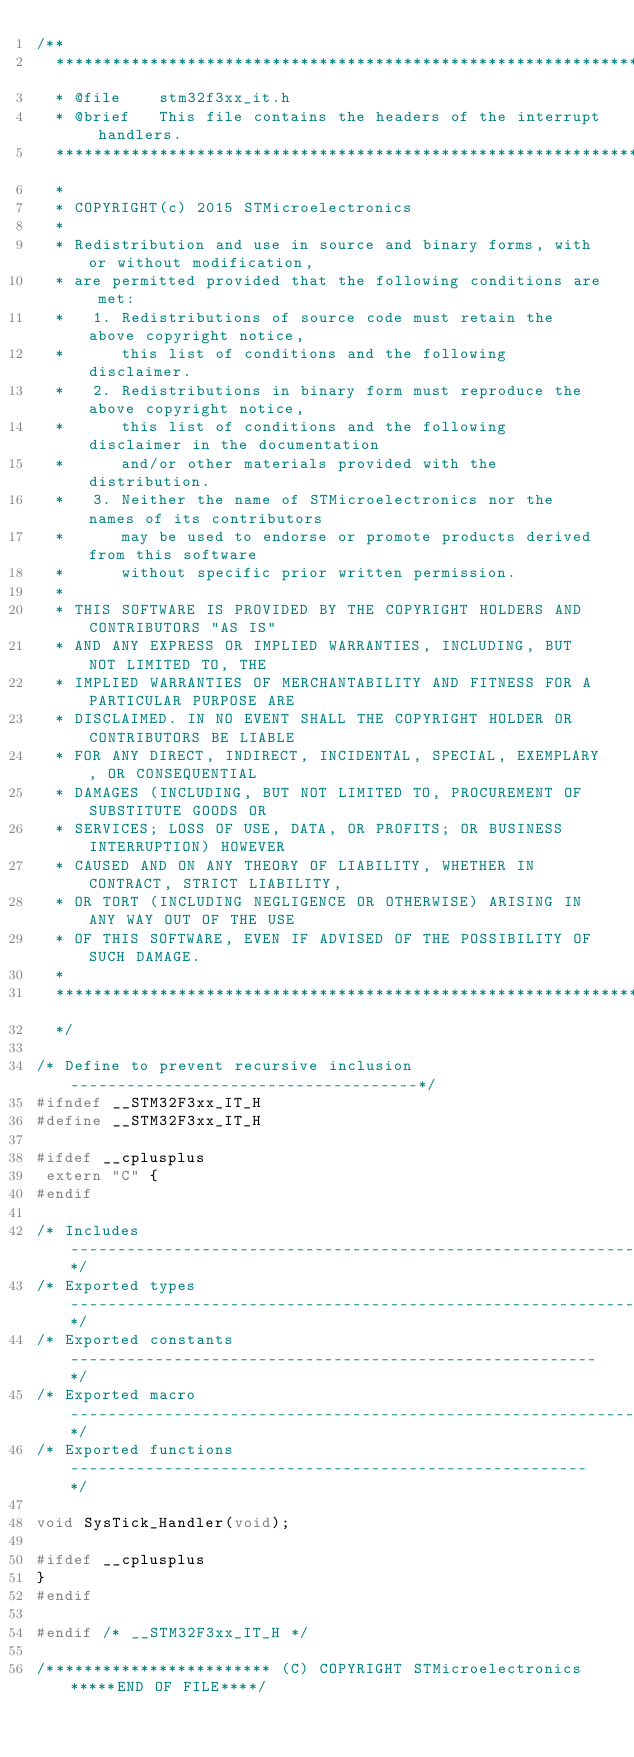<code> <loc_0><loc_0><loc_500><loc_500><_C_>/**
  ******************************************************************************
  * @file    stm32f3xx_it.h
  * @brief   This file contains the headers of the interrupt handlers.
  ******************************************************************************
  *
  * COPYRIGHT(c) 2015 STMicroelectronics
  *
  * Redistribution and use in source and binary forms, with or without modification,
  * are permitted provided that the following conditions are met:
  *   1. Redistributions of source code must retain the above copyright notice,
  *      this list of conditions and the following disclaimer.
  *   2. Redistributions in binary form must reproduce the above copyright notice,
  *      this list of conditions and the following disclaimer in the documentation
  *      and/or other materials provided with the distribution.
  *   3. Neither the name of STMicroelectronics nor the names of its contributors
  *      may be used to endorse or promote products derived from this software
  *      without specific prior written permission.
  *
  * THIS SOFTWARE IS PROVIDED BY THE COPYRIGHT HOLDERS AND CONTRIBUTORS "AS IS"
  * AND ANY EXPRESS OR IMPLIED WARRANTIES, INCLUDING, BUT NOT LIMITED TO, THE
  * IMPLIED WARRANTIES OF MERCHANTABILITY AND FITNESS FOR A PARTICULAR PURPOSE ARE
  * DISCLAIMED. IN NO EVENT SHALL THE COPYRIGHT HOLDER OR CONTRIBUTORS BE LIABLE
  * FOR ANY DIRECT, INDIRECT, INCIDENTAL, SPECIAL, EXEMPLARY, OR CONSEQUENTIAL
  * DAMAGES (INCLUDING, BUT NOT LIMITED TO, PROCUREMENT OF SUBSTITUTE GOODS OR
  * SERVICES; LOSS OF USE, DATA, OR PROFITS; OR BUSINESS INTERRUPTION) HOWEVER
  * CAUSED AND ON ANY THEORY OF LIABILITY, WHETHER IN CONTRACT, STRICT LIABILITY,
  * OR TORT (INCLUDING NEGLIGENCE OR OTHERWISE) ARISING IN ANY WAY OUT OF THE USE
  * OF THIS SOFTWARE, EVEN IF ADVISED OF THE POSSIBILITY OF SUCH DAMAGE.
  *
  ******************************************************************************
  */

/* Define to prevent recursive inclusion -------------------------------------*/
#ifndef __STM32F3xx_IT_H
#define __STM32F3xx_IT_H

#ifdef __cplusplus
 extern "C" {
#endif 

/* Includes ------------------------------------------------------------------*/
/* Exported types ------------------------------------------------------------*/
/* Exported constants --------------------------------------------------------*/
/* Exported macro ------------------------------------------------------------*/
/* Exported functions ------------------------------------------------------- */

void SysTick_Handler(void);

#ifdef __cplusplus
}
#endif

#endif /* __STM32F3xx_IT_H */

/************************ (C) COPYRIGHT STMicroelectronics *****END OF FILE****/
</code> 